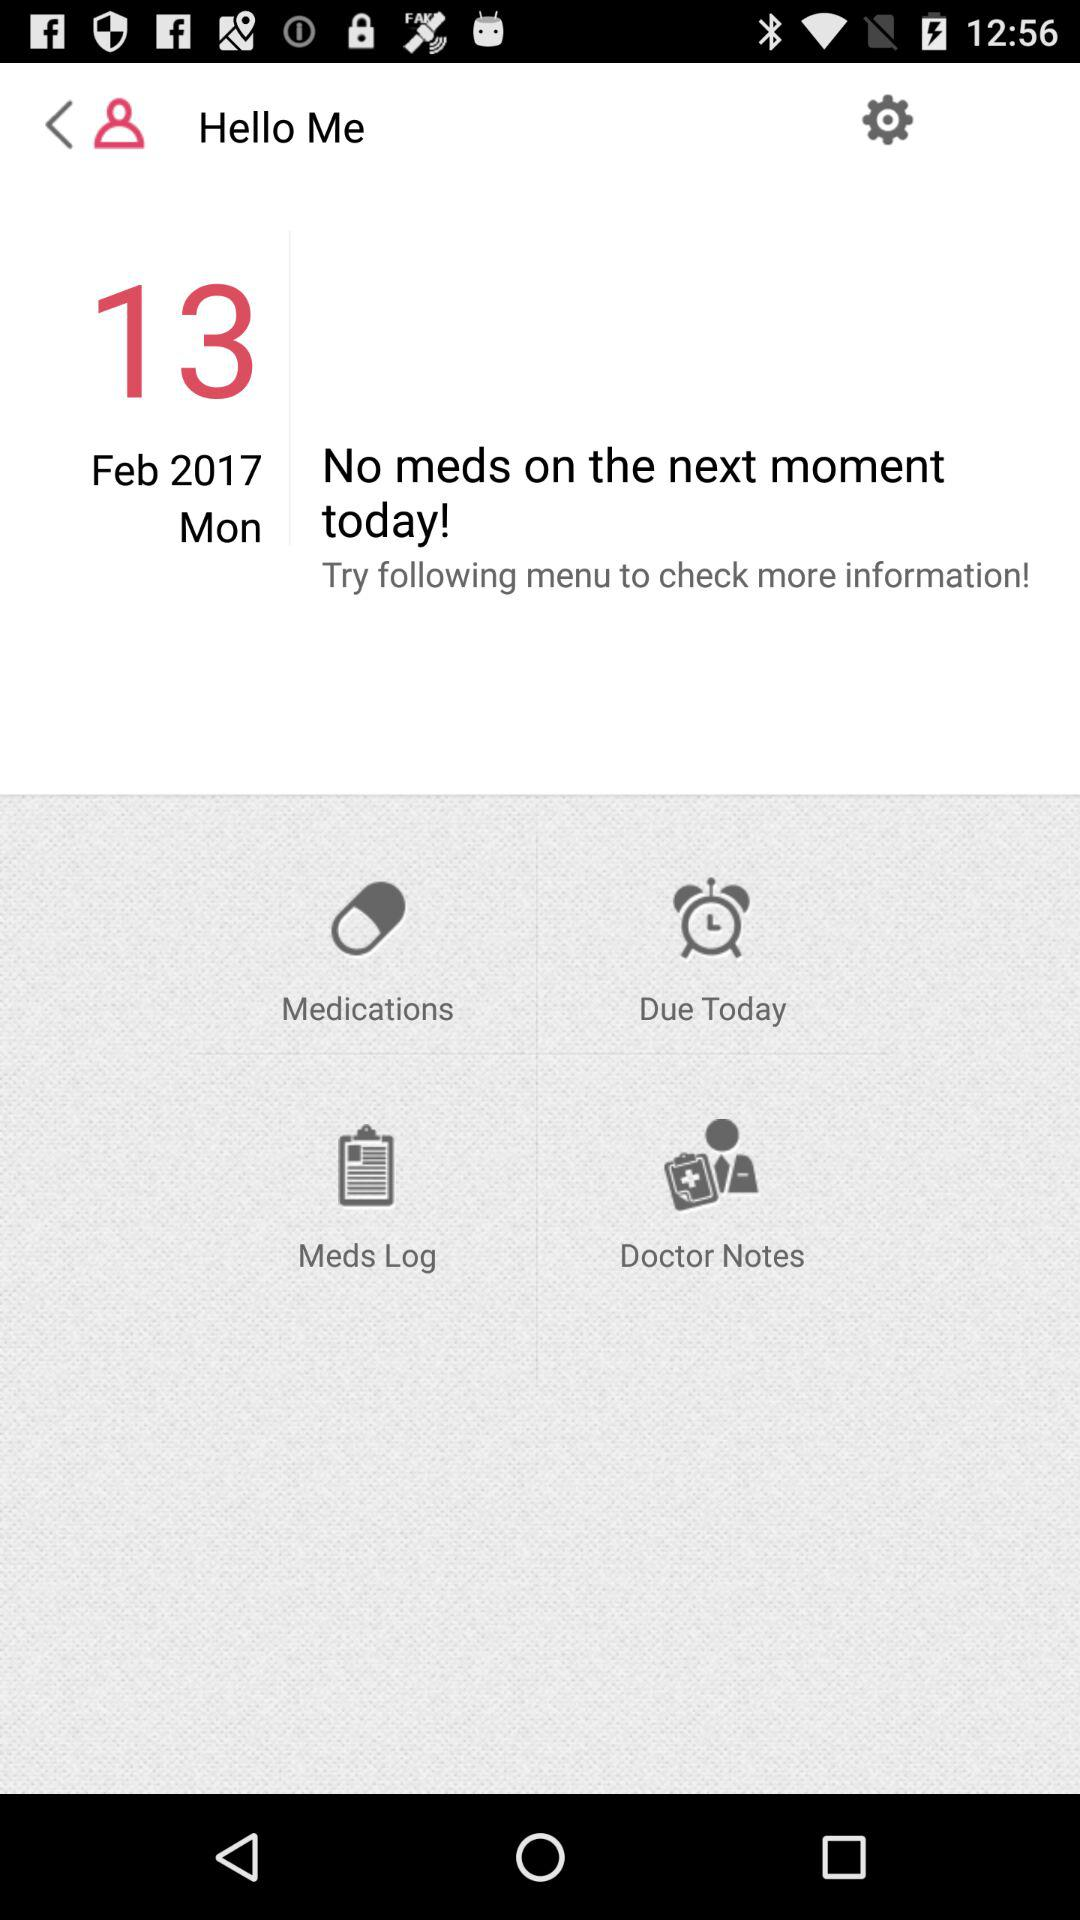What is the given date? The date is Monday, February 13, 2017. 